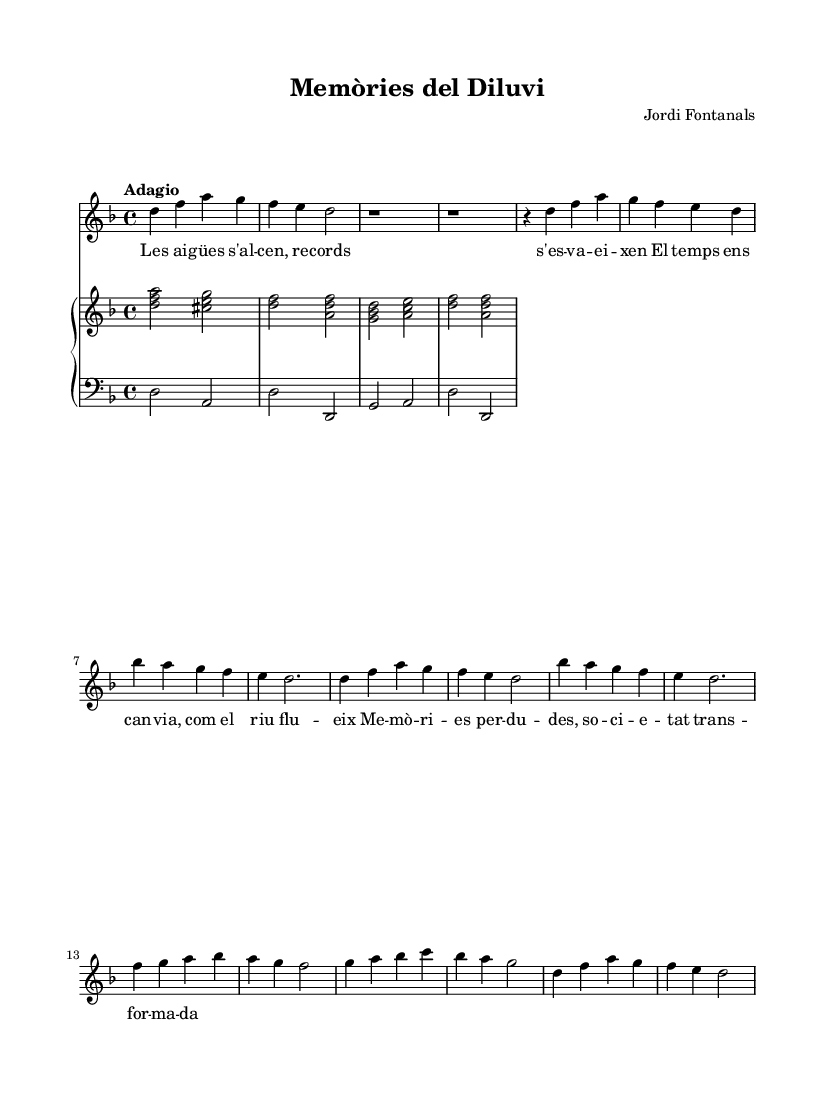What is the time signature of this music? The time signature shown at the beginning of the sheet music is 4/4, which indicates four beats per measure.
Answer: 4/4 What is the key signature of this piece? The key signature is indicated by the presence of one flat, which corresponds to the key of D minor.
Answer: D minor What tempo marking is used in this composition? The tempo marking at the beginning of the score is "Adagio," which means a slow tempo.
Answer: Adagio How many sections does the aria have? The aria consists of two sections labeled A and B, suggesting a structure that often includes contrasting musical ideas.
Answer: Two sections What is the thematic focus of the lyrics? The lyrics convey themes of memory, loss, and societal change, reflecting emotions tied to the passage of time.
Answer: Memory, loss, and societal change Which voice type is performing this piece? The voice type indicated for this part is "soprano," which is typically the highest vocal range in choral music.
Answer: Soprano How does the music represent the concept of transformation? The music uses melodic variations and harmonic progressions to illustrate the theme of transformation, reflecting societal changes over time.
Answer: Melodic variations and harmonic progressions 